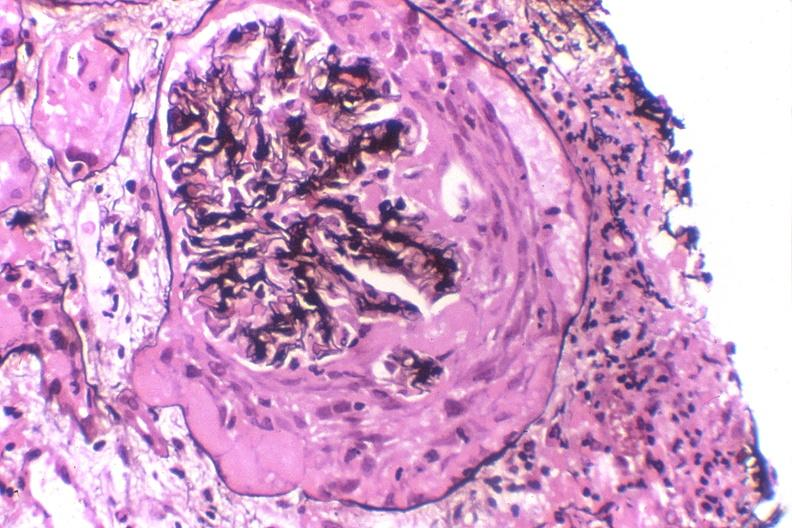what does this image show?
Answer the question using a single word or phrase. Crescentric glomerulonephritis 